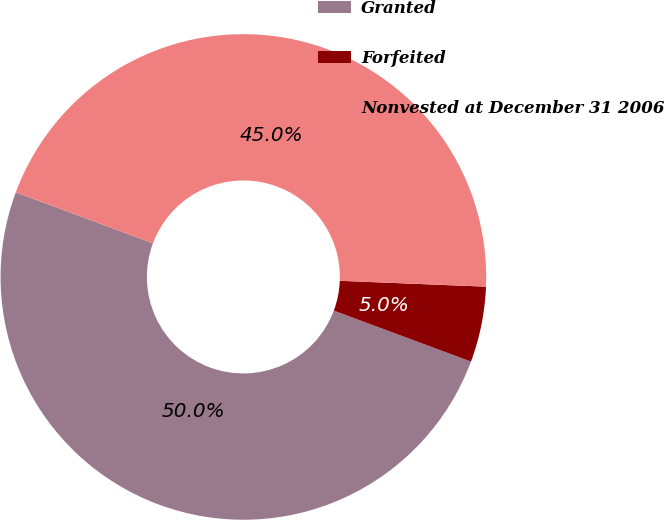Convert chart to OTSL. <chart><loc_0><loc_0><loc_500><loc_500><pie_chart><fcel>Granted<fcel>Forfeited<fcel>Nonvested at December 31 2006<nl><fcel>50.0%<fcel>5.03%<fcel>44.97%<nl></chart> 